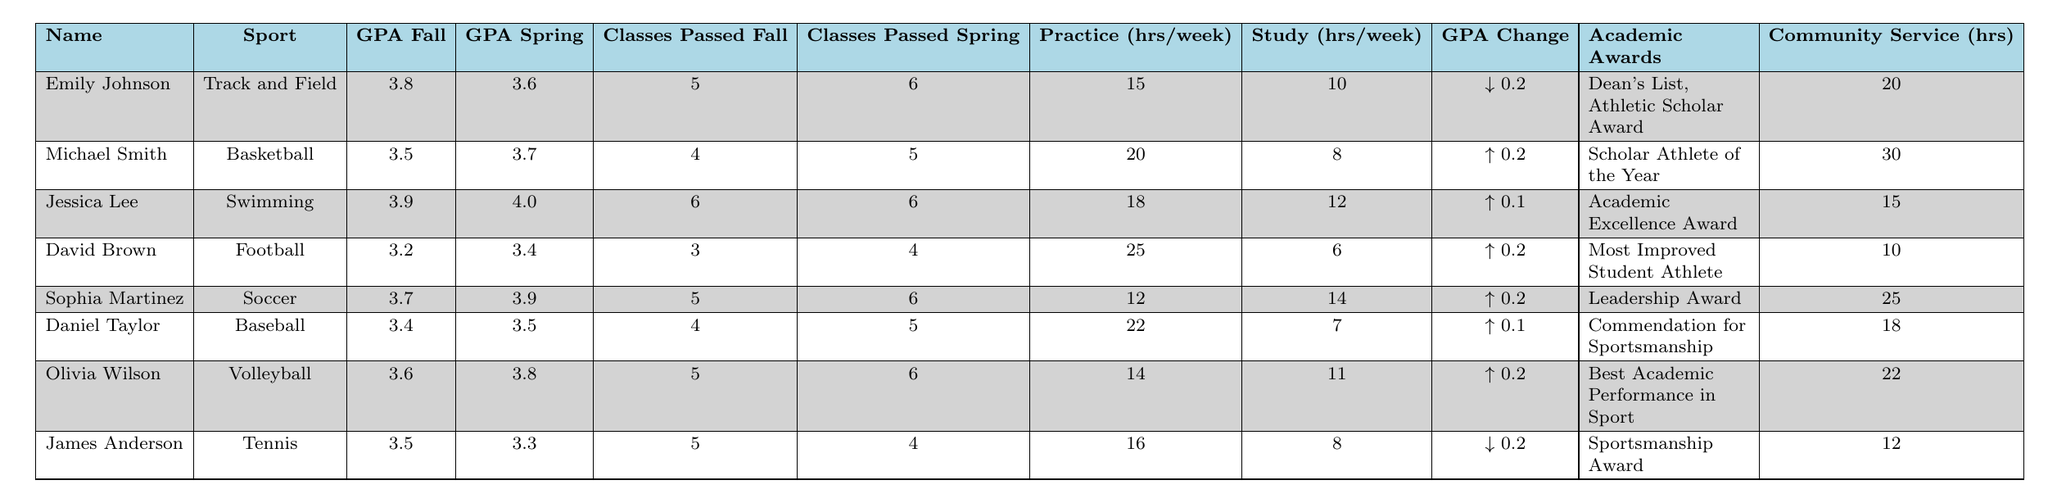What is the highest GPA in the fall semester? To find the highest GPA in the fall semester, I will look at the "GPA Fall" values in the table: 3.8, 3.5, 3.9, 3.2, 3.7, 3.4, 3.6, and 3.5. The highest value among these is 3.9, which belongs to Jessica Lee.
Answer: 3.9 How many classes did Michael Smith pass in the spring semester? To answer this question, I will reference the "Classes Passed Spring" column for Michael Smith, which shows he passed 5 classes in the spring semester.
Answer: 5 Who received the "Best Academic Performance in Sport" award? I will look at the "Academic Awards" column to identify which student received the specific award. According to the table, Olivia Wilson received the "Best Academic Performance in Sport" award.
Answer: Olivia Wilson What is the total number of community service hours contributed by all student-athletes? To find the total, I will add together the community service hours from each athlete: 20 + 30 + 15 + 10 + 25 + 18 + 22 + 12 = 152. The total community service hours contributed by all student-athletes is therefore 152.
Answer: 152 Which athlete improved their GPA from fall to spring by the most points? I will look at the GPA change for each athlete, calculating the difference between their GPA in the fall and spring. The maximum change was for Michael Smith, David Brown, Sophia Martinez, and Olivia Wilson, each showing an increase of 0.2, with Michael Smith having the highest GPA improvement from 3.5 to 3.7.
Answer: Michael Smith How many hours do athletes with a GPA above 3.5 generally study per week? I will consider the athletes with a GPA above 3.5: Emily Johnson, Jessica Lee, Sophia Martinez, and Olivia Wilson. Their study hours are: 10, 12, 14, and 11, respectively. The average is (10 + 12 + 14 + 11) / 4 = 11.75 hours per week.
Answer: 11.75 Did James Anderson's GPA decrease in the spring semester? I will check James Anderson's GPAs for both semesters: Fall 3.5 and Spring 3.3. Since 3.3 is less than 3.5, it indicates that his GPA did decrease in the spring semester.
Answer: Yes What is the average number of classes passed by students who practice for more than 20 hours per week? To find this average, I will identify students practicing more than 20 hours per week: Michael Smith (20), David Brown (25), and Daniel Taylor (22). Their classes passed are 5, 4, and 5, respectively. The average is (4 + 5 + 5) / 3 = 4.67.
Answer: 4.67 Which sport had the student with the highest community service hours? I will look at the community service hours and identify the sport corresponding to the highest value—Michael Smith had 30 hours of community service, participating in Basketball.
Answer: Basketball How did Jessica Lee's GPA change from fall to spring? I can find this by comparing Jessica Lee's GPA in the fall (3.9) to her spring GPA (4.0). The change is 4.0 - 3.9 = 0.1, indicating a positive improvement.
Answer: 0.1 Which athlete had the least number of classes passed in the fall semester? I will refer to the "Classes Passed Fall" column to find the lowest number: the values are 5, 4, 6, 3, 5, 4, 5, 5, with David Brown having the least at 3 classes passed.
Answer: David Brown 